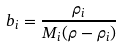<formula> <loc_0><loc_0><loc_500><loc_500>b _ { i } = \frac { \rho _ { i } } { M _ { i } ( \rho - \rho _ { i } ) }</formula> 